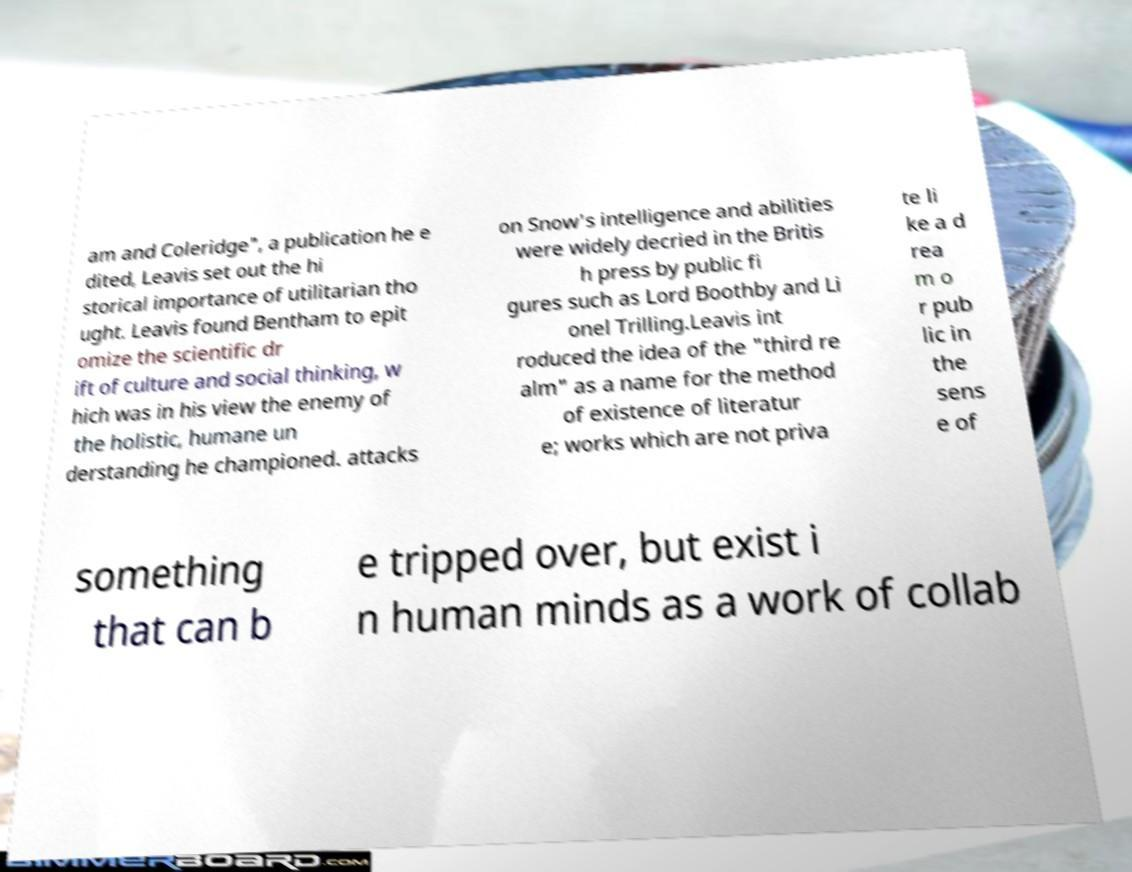There's text embedded in this image that I need extracted. Can you transcribe it verbatim? am and Coleridge", a publication he e dited, Leavis set out the hi storical importance of utilitarian tho ught. Leavis found Bentham to epit omize the scientific dr ift of culture and social thinking, w hich was in his view the enemy of the holistic, humane un derstanding he championed. attacks on Snow's intelligence and abilities were widely decried in the Britis h press by public fi gures such as Lord Boothby and Li onel Trilling.Leavis int roduced the idea of the "third re alm" as a name for the method of existence of literatur e; works which are not priva te li ke a d rea m o r pub lic in the sens e of something that can b e tripped over, but exist i n human minds as a work of collab 